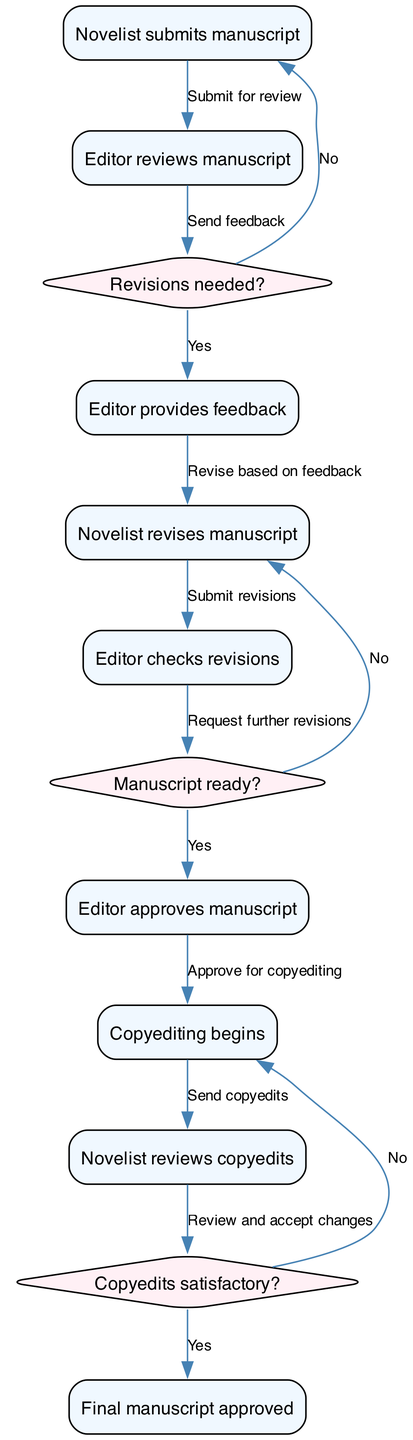What is the first action in the workflow? The first action is represented by the first node, which states that the novelist submits the manuscript. This can be easily identified in the diagram as the starting point.
Answer: Novelist submits manuscript How many nodes are present in the diagram? Counting the listed nodes in the data provided, there are a total of 9 nodes, which represent different stages in the editing workflow.
Answer: 9 What is the decision made after the editor reviews the manuscript? After the editor reviews the manuscript, the decision is whether revisions are needed or not. This decision node is directly linked to the reviewing process.
Answer: Revisions needed? What happens if the decision "Revisions needed?" is answered with "Yes"? If "Yes," the editor provides feedback, which leads to the novelist revising the manuscript. The flow continues with necessary steps that depend on this decision.
Answer: Novelist revises manuscript Which node comes directly after the editor checks revisions? The node that follows the editor checking revisions is the one where the editor approves the manuscript, indicating a successful transition to acceptance.
Answer: Editor approves manuscript What action is taken after the manuscript is approved? Once the manuscript is approved by the editor, copyediting begins, marking the transition to a different stage in the workflow.
Answer: Copyediting begins What is the final status in the workflow? The final node in the workflow indicates that the final manuscript is approved, which shows the end of the editing process.
Answer: Final manuscript approved How many decision nodes are present in the diagram? There are 3 decision nodes identified in the diagram which assist in determining the next steps based on different conditions throughout the workflow.
Answer: 3 What is the last action taken before preparing the manuscript for publication? Before preparing the manuscript for publication, the novelist reviews copyedits, signifying that this is the final review step before publication preparation begins.
Answer: Novelist reviews copyedits 